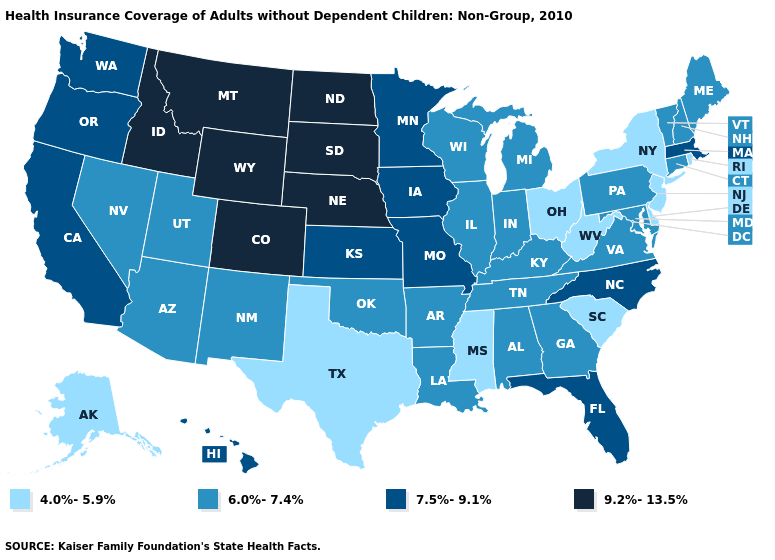What is the value of Minnesota?
Give a very brief answer. 7.5%-9.1%. What is the value of North Dakota?
Short answer required. 9.2%-13.5%. Does Michigan have a lower value than Utah?
Concise answer only. No. How many symbols are there in the legend?
Concise answer only. 4. What is the lowest value in the USA?
Answer briefly. 4.0%-5.9%. Among the states that border Louisiana , does Arkansas have the highest value?
Short answer required. Yes. Name the states that have a value in the range 7.5%-9.1%?
Write a very short answer. California, Florida, Hawaii, Iowa, Kansas, Massachusetts, Minnesota, Missouri, North Carolina, Oregon, Washington. Name the states that have a value in the range 4.0%-5.9%?
Write a very short answer. Alaska, Delaware, Mississippi, New Jersey, New York, Ohio, Rhode Island, South Carolina, Texas, West Virginia. Name the states that have a value in the range 6.0%-7.4%?
Answer briefly. Alabama, Arizona, Arkansas, Connecticut, Georgia, Illinois, Indiana, Kentucky, Louisiana, Maine, Maryland, Michigan, Nevada, New Hampshire, New Mexico, Oklahoma, Pennsylvania, Tennessee, Utah, Vermont, Virginia, Wisconsin. Name the states that have a value in the range 6.0%-7.4%?
Concise answer only. Alabama, Arizona, Arkansas, Connecticut, Georgia, Illinois, Indiana, Kentucky, Louisiana, Maine, Maryland, Michigan, Nevada, New Hampshire, New Mexico, Oklahoma, Pennsylvania, Tennessee, Utah, Vermont, Virginia, Wisconsin. Does Massachusetts have a higher value than Kansas?
Quick response, please. No. What is the value of Utah?
Concise answer only. 6.0%-7.4%. How many symbols are there in the legend?
Write a very short answer. 4. Among the states that border Missouri , does Iowa have the lowest value?
Answer briefly. No. What is the value of Pennsylvania?
Be succinct. 6.0%-7.4%. 